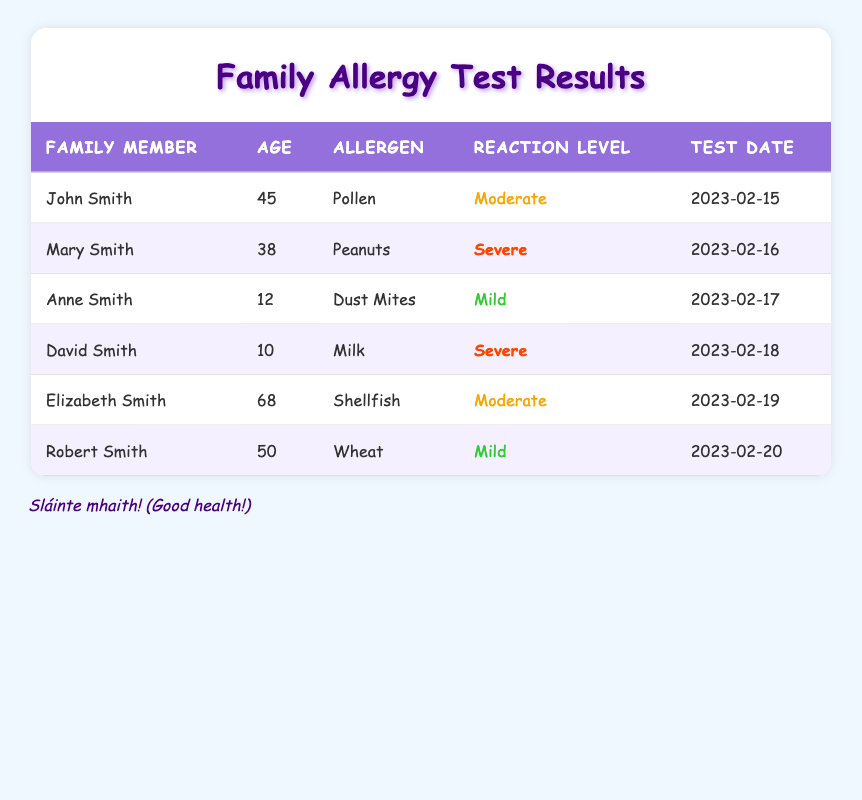What allergen does John Smith have? John Smith's allergen is listed in the table under the "Allergen" column. According to the table, he has a reaction to pollen.
Answer: Pollen How many family members have a severe reaction to allergens? By looking at the "Reaction Level" column, we can identify the family members with a severe reaction. Mary Smith and David Smith are the only two with a severe reaction.
Answer: 2 Which family member is the oldest? To find the oldest family member, we need to compare the ages in the "Age" column. Elizabeth Smith is 68 years old, which is the highest age listed.
Answer: Elizabeth Smith What is the average age of family members who have a mild reaction? The family members with a mild reaction are Anne Smith (12) and Robert Smith (50). We sum their ages (12 + 50 = 62) and divide by the number of members (2) to find the average age is 31.
Answer: 31 Is it true that no family members have a reaction to eggs? The table does not list any allergens related to eggs; it only includes pollen, peanuts, dust mites, milk, shellfish, and wheat. Therefore, the statement is true.
Answer: Yes What is the most common allergen reaction level reported in this table? We need to analyze the "Reaction Level" column to find which level appears most frequently. The levels are moderate (3), severe (2), and mild (2). Thus, the most common is moderate.
Answer: Moderate How many different allergens are documented in the family allergies? Looking at the "Allergen" column, we find the distinct allergens listed: pollen, peanuts, dust mites, milk, shellfish, and wheat. There are 6 unique allergens in total.
Answer: 6 What is the date of the most recent allergy test? The test dates are listed in the "Test Date" column. The latest date is February 20, 2023, corresponding to Robert Smith's test.
Answer: 2023-02-20 Who is the youngest family member and what allergen do they react to? From the "Age" column, David Smith is the youngest at 10 years old, and he has a severe reaction to milk according to the "Allergen" column.
Answer: David Smith and Milk 